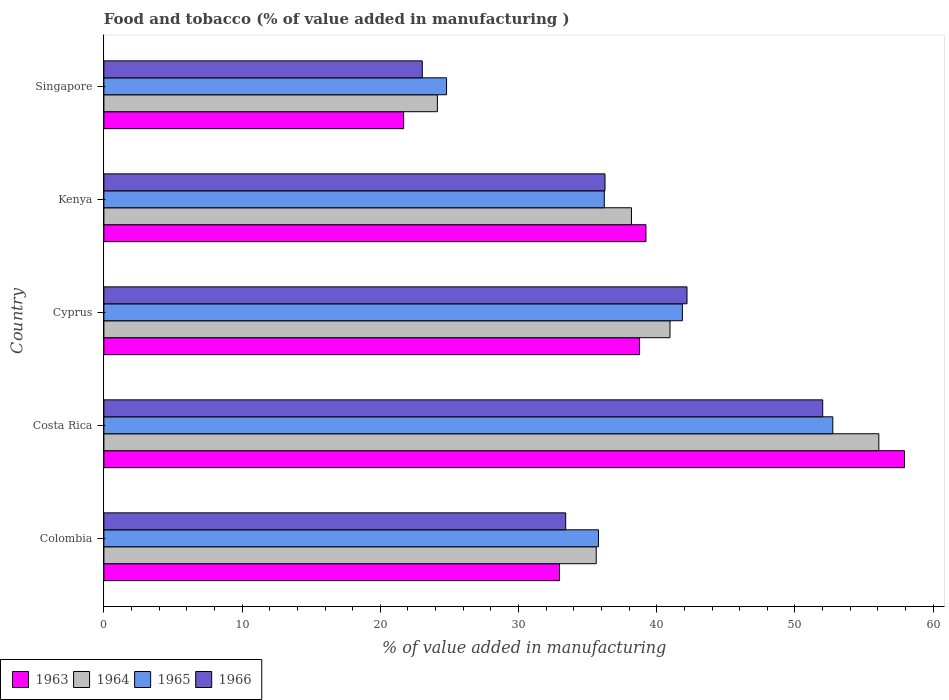How many groups of bars are there?
Provide a short and direct response. 5. How many bars are there on the 2nd tick from the bottom?
Your response must be concise. 4. What is the label of the 4th group of bars from the top?
Ensure brevity in your answer.  Costa Rica. What is the value added in manufacturing food and tobacco in 1965 in Colombia?
Provide a short and direct response. 35.78. Across all countries, what is the maximum value added in manufacturing food and tobacco in 1965?
Keep it short and to the point. 52.73. Across all countries, what is the minimum value added in manufacturing food and tobacco in 1965?
Your answer should be very brief. 24.79. In which country was the value added in manufacturing food and tobacco in 1964 minimum?
Make the answer very short. Singapore. What is the total value added in manufacturing food and tobacco in 1965 in the graph?
Offer a very short reply. 191.36. What is the difference between the value added in manufacturing food and tobacco in 1966 in Cyprus and that in Kenya?
Offer a terse response. 5.93. What is the difference between the value added in manufacturing food and tobacco in 1965 in Kenya and the value added in manufacturing food and tobacco in 1966 in Costa Rica?
Give a very brief answer. -15.8. What is the average value added in manufacturing food and tobacco in 1963 per country?
Offer a terse response. 38.11. What is the difference between the value added in manufacturing food and tobacco in 1963 and value added in manufacturing food and tobacco in 1966 in Colombia?
Your answer should be compact. -0.45. In how many countries, is the value added in manufacturing food and tobacco in 1965 greater than 6 %?
Provide a succinct answer. 5. What is the ratio of the value added in manufacturing food and tobacco in 1964 in Colombia to that in Cyprus?
Give a very brief answer. 0.87. Is the value added in manufacturing food and tobacco in 1964 in Cyprus less than that in Singapore?
Ensure brevity in your answer.  No. Is the difference between the value added in manufacturing food and tobacco in 1963 in Costa Rica and Kenya greater than the difference between the value added in manufacturing food and tobacco in 1966 in Costa Rica and Kenya?
Ensure brevity in your answer.  Yes. What is the difference between the highest and the second highest value added in manufacturing food and tobacco in 1964?
Ensure brevity in your answer.  15.11. What is the difference between the highest and the lowest value added in manufacturing food and tobacco in 1964?
Give a very brief answer. 31.94. In how many countries, is the value added in manufacturing food and tobacco in 1966 greater than the average value added in manufacturing food and tobacco in 1966 taken over all countries?
Ensure brevity in your answer.  2. What does the 3rd bar from the top in Kenya represents?
Your response must be concise. 1964. What does the 2nd bar from the bottom in Singapore represents?
Make the answer very short. 1964. Is it the case that in every country, the sum of the value added in manufacturing food and tobacco in 1965 and value added in manufacturing food and tobacco in 1964 is greater than the value added in manufacturing food and tobacco in 1966?
Your answer should be compact. Yes. What is the difference between two consecutive major ticks on the X-axis?
Offer a very short reply. 10. Where does the legend appear in the graph?
Offer a terse response. Bottom left. How many legend labels are there?
Make the answer very short. 4. How are the legend labels stacked?
Give a very brief answer. Horizontal. What is the title of the graph?
Offer a very short reply. Food and tobacco (% of value added in manufacturing ). Does "1997" appear as one of the legend labels in the graph?
Keep it short and to the point. No. What is the label or title of the X-axis?
Give a very brief answer. % of value added in manufacturing. What is the % of value added in manufacturing in 1963 in Colombia?
Give a very brief answer. 32.96. What is the % of value added in manufacturing of 1964 in Colombia?
Give a very brief answer. 35.62. What is the % of value added in manufacturing of 1965 in Colombia?
Your answer should be very brief. 35.78. What is the % of value added in manufacturing of 1966 in Colombia?
Make the answer very short. 33.41. What is the % of value added in manufacturing of 1963 in Costa Rica?
Make the answer very short. 57.92. What is the % of value added in manufacturing of 1964 in Costa Rica?
Keep it short and to the point. 56.07. What is the % of value added in manufacturing in 1965 in Costa Rica?
Offer a terse response. 52.73. What is the % of value added in manufacturing in 1966 in Costa Rica?
Offer a very short reply. 52. What is the % of value added in manufacturing in 1963 in Cyprus?
Provide a short and direct response. 38.75. What is the % of value added in manufacturing of 1964 in Cyprus?
Offer a terse response. 40.96. What is the % of value added in manufacturing in 1965 in Cyprus?
Your response must be concise. 41.85. What is the % of value added in manufacturing of 1966 in Cyprus?
Provide a succinct answer. 42.19. What is the % of value added in manufacturing of 1963 in Kenya?
Your answer should be very brief. 39.22. What is the % of value added in manufacturing in 1964 in Kenya?
Give a very brief answer. 38.17. What is the % of value added in manufacturing of 1965 in Kenya?
Your response must be concise. 36.2. What is the % of value added in manufacturing in 1966 in Kenya?
Ensure brevity in your answer.  36.25. What is the % of value added in manufacturing in 1963 in Singapore?
Ensure brevity in your answer.  21.69. What is the % of value added in manufacturing in 1964 in Singapore?
Keep it short and to the point. 24.13. What is the % of value added in manufacturing of 1965 in Singapore?
Keep it short and to the point. 24.79. What is the % of value added in manufacturing of 1966 in Singapore?
Your response must be concise. 23.04. Across all countries, what is the maximum % of value added in manufacturing of 1963?
Ensure brevity in your answer.  57.92. Across all countries, what is the maximum % of value added in manufacturing in 1964?
Give a very brief answer. 56.07. Across all countries, what is the maximum % of value added in manufacturing in 1965?
Offer a terse response. 52.73. Across all countries, what is the maximum % of value added in manufacturing of 1966?
Offer a terse response. 52. Across all countries, what is the minimum % of value added in manufacturing in 1963?
Provide a short and direct response. 21.69. Across all countries, what is the minimum % of value added in manufacturing in 1964?
Your response must be concise. 24.13. Across all countries, what is the minimum % of value added in manufacturing of 1965?
Provide a short and direct response. 24.79. Across all countries, what is the minimum % of value added in manufacturing in 1966?
Your answer should be compact. 23.04. What is the total % of value added in manufacturing of 1963 in the graph?
Give a very brief answer. 190.54. What is the total % of value added in manufacturing of 1964 in the graph?
Your answer should be very brief. 194.94. What is the total % of value added in manufacturing of 1965 in the graph?
Your answer should be very brief. 191.36. What is the total % of value added in manufacturing of 1966 in the graph?
Your answer should be compact. 186.89. What is the difference between the % of value added in manufacturing of 1963 in Colombia and that in Costa Rica?
Your answer should be very brief. -24.96. What is the difference between the % of value added in manufacturing of 1964 in Colombia and that in Costa Rica?
Your answer should be compact. -20.45. What is the difference between the % of value added in manufacturing of 1965 in Colombia and that in Costa Rica?
Give a very brief answer. -16.95. What is the difference between the % of value added in manufacturing of 1966 in Colombia and that in Costa Rica?
Your answer should be compact. -18.59. What is the difference between the % of value added in manufacturing of 1963 in Colombia and that in Cyprus?
Give a very brief answer. -5.79. What is the difference between the % of value added in manufacturing in 1964 in Colombia and that in Cyprus?
Your answer should be very brief. -5.34. What is the difference between the % of value added in manufacturing in 1965 in Colombia and that in Cyprus?
Your answer should be compact. -6.07. What is the difference between the % of value added in manufacturing in 1966 in Colombia and that in Cyprus?
Provide a short and direct response. -8.78. What is the difference between the % of value added in manufacturing of 1963 in Colombia and that in Kenya?
Give a very brief answer. -6.26. What is the difference between the % of value added in manufacturing in 1964 in Colombia and that in Kenya?
Keep it short and to the point. -2.55. What is the difference between the % of value added in manufacturing of 1965 in Colombia and that in Kenya?
Your answer should be compact. -0.42. What is the difference between the % of value added in manufacturing in 1966 in Colombia and that in Kenya?
Provide a short and direct response. -2.84. What is the difference between the % of value added in manufacturing in 1963 in Colombia and that in Singapore?
Give a very brief answer. 11.27. What is the difference between the % of value added in manufacturing of 1964 in Colombia and that in Singapore?
Your response must be concise. 11.49. What is the difference between the % of value added in manufacturing in 1965 in Colombia and that in Singapore?
Your answer should be very brief. 10.99. What is the difference between the % of value added in manufacturing in 1966 in Colombia and that in Singapore?
Keep it short and to the point. 10.37. What is the difference between the % of value added in manufacturing of 1963 in Costa Rica and that in Cyprus?
Offer a terse response. 19.17. What is the difference between the % of value added in manufacturing of 1964 in Costa Rica and that in Cyprus?
Your response must be concise. 15.11. What is the difference between the % of value added in manufacturing of 1965 in Costa Rica and that in Cyprus?
Your answer should be very brief. 10.88. What is the difference between the % of value added in manufacturing in 1966 in Costa Rica and that in Cyprus?
Ensure brevity in your answer.  9.82. What is the difference between the % of value added in manufacturing in 1963 in Costa Rica and that in Kenya?
Keep it short and to the point. 18.7. What is the difference between the % of value added in manufacturing in 1964 in Costa Rica and that in Kenya?
Provide a succinct answer. 17.9. What is the difference between the % of value added in manufacturing in 1965 in Costa Rica and that in Kenya?
Provide a short and direct response. 16.53. What is the difference between the % of value added in manufacturing in 1966 in Costa Rica and that in Kenya?
Offer a terse response. 15.75. What is the difference between the % of value added in manufacturing in 1963 in Costa Rica and that in Singapore?
Your response must be concise. 36.23. What is the difference between the % of value added in manufacturing in 1964 in Costa Rica and that in Singapore?
Your response must be concise. 31.94. What is the difference between the % of value added in manufacturing in 1965 in Costa Rica and that in Singapore?
Provide a succinct answer. 27.94. What is the difference between the % of value added in manufacturing in 1966 in Costa Rica and that in Singapore?
Offer a terse response. 28.97. What is the difference between the % of value added in manufacturing of 1963 in Cyprus and that in Kenya?
Ensure brevity in your answer.  -0.46. What is the difference between the % of value added in manufacturing of 1964 in Cyprus and that in Kenya?
Your response must be concise. 2.79. What is the difference between the % of value added in manufacturing in 1965 in Cyprus and that in Kenya?
Your response must be concise. 5.65. What is the difference between the % of value added in manufacturing of 1966 in Cyprus and that in Kenya?
Give a very brief answer. 5.93. What is the difference between the % of value added in manufacturing of 1963 in Cyprus and that in Singapore?
Give a very brief answer. 17.07. What is the difference between the % of value added in manufacturing in 1964 in Cyprus and that in Singapore?
Provide a short and direct response. 16.83. What is the difference between the % of value added in manufacturing in 1965 in Cyprus and that in Singapore?
Give a very brief answer. 17.06. What is the difference between the % of value added in manufacturing of 1966 in Cyprus and that in Singapore?
Give a very brief answer. 19.15. What is the difference between the % of value added in manufacturing of 1963 in Kenya and that in Singapore?
Offer a very short reply. 17.53. What is the difference between the % of value added in manufacturing of 1964 in Kenya and that in Singapore?
Your response must be concise. 14.04. What is the difference between the % of value added in manufacturing in 1965 in Kenya and that in Singapore?
Provide a short and direct response. 11.41. What is the difference between the % of value added in manufacturing of 1966 in Kenya and that in Singapore?
Your answer should be very brief. 13.22. What is the difference between the % of value added in manufacturing of 1963 in Colombia and the % of value added in manufacturing of 1964 in Costa Rica?
Offer a terse response. -23.11. What is the difference between the % of value added in manufacturing in 1963 in Colombia and the % of value added in manufacturing in 1965 in Costa Rica?
Keep it short and to the point. -19.77. What is the difference between the % of value added in manufacturing of 1963 in Colombia and the % of value added in manufacturing of 1966 in Costa Rica?
Give a very brief answer. -19.04. What is the difference between the % of value added in manufacturing of 1964 in Colombia and the % of value added in manufacturing of 1965 in Costa Rica?
Provide a short and direct response. -17.11. What is the difference between the % of value added in manufacturing in 1964 in Colombia and the % of value added in manufacturing in 1966 in Costa Rica?
Give a very brief answer. -16.38. What is the difference between the % of value added in manufacturing in 1965 in Colombia and the % of value added in manufacturing in 1966 in Costa Rica?
Your answer should be very brief. -16.22. What is the difference between the % of value added in manufacturing of 1963 in Colombia and the % of value added in manufacturing of 1964 in Cyprus?
Your response must be concise. -8. What is the difference between the % of value added in manufacturing of 1963 in Colombia and the % of value added in manufacturing of 1965 in Cyprus?
Provide a succinct answer. -8.89. What is the difference between the % of value added in manufacturing of 1963 in Colombia and the % of value added in manufacturing of 1966 in Cyprus?
Provide a short and direct response. -9.23. What is the difference between the % of value added in manufacturing of 1964 in Colombia and the % of value added in manufacturing of 1965 in Cyprus?
Make the answer very short. -6.23. What is the difference between the % of value added in manufacturing in 1964 in Colombia and the % of value added in manufacturing in 1966 in Cyprus?
Offer a very short reply. -6.57. What is the difference between the % of value added in manufacturing in 1965 in Colombia and the % of value added in manufacturing in 1966 in Cyprus?
Your response must be concise. -6.41. What is the difference between the % of value added in manufacturing in 1963 in Colombia and the % of value added in manufacturing in 1964 in Kenya?
Offer a very short reply. -5.21. What is the difference between the % of value added in manufacturing of 1963 in Colombia and the % of value added in manufacturing of 1965 in Kenya?
Give a very brief answer. -3.24. What is the difference between the % of value added in manufacturing in 1963 in Colombia and the % of value added in manufacturing in 1966 in Kenya?
Make the answer very short. -3.29. What is the difference between the % of value added in manufacturing in 1964 in Colombia and the % of value added in manufacturing in 1965 in Kenya?
Keep it short and to the point. -0.58. What is the difference between the % of value added in manufacturing of 1964 in Colombia and the % of value added in manufacturing of 1966 in Kenya?
Your answer should be very brief. -0.63. What is the difference between the % of value added in manufacturing of 1965 in Colombia and the % of value added in manufacturing of 1966 in Kenya?
Offer a terse response. -0.47. What is the difference between the % of value added in manufacturing in 1963 in Colombia and the % of value added in manufacturing in 1964 in Singapore?
Ensure brevity in your answer.  8.83. What is the difference between the % of value added in manufacturing in 1963 in Colombia and the % of value added in manufacturing in 1965 in Singapore?
Provide a succinct answer. 8.17. What is the difference between the % of value added in manufacturing in 1963 in Colombia and the % of value added in manufacturing in 1966 in Singapore?
Offer a terse response. 9.92. What is the difference between the % of value added in manufacturing of 1964 in Colombia and the % of value added in manufacturing of 1965 in Singapore?
Ensure brevity in your answer.  10.83. What is the difference between the % of value added in manufacturing in 1964 in Colombia and the % of value added in manufacturing in 1966 in Singapore?
Provide a succinct answer. 12.58. What is the difference between the % of value added in manufacturing in 1965 in Colombia and the % of value added in manufacturing in 1966 in Singapore?
Your answer should be compact. 12.74. What is the difference between the % of value added in manufacturing in 1963 in Costa Rica and the % of value added in manufacturing in 1964 in Cyprus?
Your answer should be compact. 16.96. What is the difference between the % of value added in manufacturing of 1963 in Costa Rica and the % of value added in manufacturing of 1965 in Cyprus?
Your answer should be compact. 16.07. What is the difference between the % of value added in manufacturing of 1963 in Costa Rica and the % of value added in manufacturing of 1966 in Cyprus?
Ensure brevity in your answer.  15.73. What is the difference between the % of value added in manufacturing of 1964 in Costa Rica and the % of value added in manufacturing of 1965 in Cyprus?
Your response must be concise. 14.21. What is the difference between the % of value added in manufacturing of 1964 in Costa Rica and the % of value added in manufacturing of 1966 in Cyprus?
Your answer should be very brief. 13.88. What is the difference between the % of value added in manufacturing in 1965 in Costa Rica and the % of value added in manufacturing in 1966 in Cyprus?
Provide a short and direct response. 10.55. What is the difference between the % of value added in manufacturing in 1963 in Costa Rica and the % of value added in manufacturing in 1964 in Kenya?
Make the answer very short. 19.75. What is the difference between the % of value added in manufacturing of 1963 in Costa Rica and the % of value added in manufacturing of 1965 in Kenya?
Provide a short and direct response. 21.72. What is the difference between the % of value added in manufacturing of 1963 in Costa Rica and the % of value added in manufacturing of 1966 in Kenya?
Offer a terse response. 21.67. What is the difference between the % of value added in manufacturing of 1964 in Costa Rica and the % of value added in manufacturing of 1965 in Kenya?
Make the answer very short. 19.86. What is the difference between the % of value added in manufacturing in 1964 in Costa Rica and the % of value added in manufacturing in 1966 in Kenya?
Give a very brief answer. 19.81. What is the difference between the % of value added in manufacturing of 1965 in Costa Rica and the % of value added in manufacturing of 1966 in Kenya?
Provide a short and direct response. 16.48. What is the difference between the % of value added in manufacturing of 1963 in Costa Rica and the % of value added in manufacturing of 1964 in Singapore?
Offer a very short reply. 33.79. What is the difference between the % of value added in manufacturing in 1963 in Costa Rica and the % of value added in manufacturing in 1965 in Singapore?
Ensure brevity in your answer.  33.13. What is the difference between the % of value added in manufacturing in 1963 in Costa Rica and the % of value added in manufacturing in 1966 in Singapore?
Provide a succinct answer. 34.88. What is the difference between the % of value added in manufacturing of 1964 in Costa Rica and the % of value added in manufacturing of 1965 in Singapore?
Your answer should be compact. 31.28. What is the difference between the % of value added in manufacturing in 1964 in Costa Rica and the % of value added in manufacturing in 1966 in Singapore?
Keep it short and to the point. 33.03. What is the difference between the % of value added in manufacturing of 1965 in Costa Rica and the % of value added in manufacturing of 1966 in Singapore?
Keep it short and to the point. 29.7. What is the difference between the % of value added in manufacturing in 1963 in Cyprus and the % of value added in manufacturing in 1964 in Kenya?
Keep it short and to the point. 0.59. What is the difference between the % of value added in manufacturing in 1963 in Cyprus and the % of value added in manufacturing in 1965 in Kenya?
Provide a short and direct response. 2.55. What is the difference between the % of value added in manufacturing of 1963 in Cyprus and the % of value added in manufacturing of 1966 in Kenya?
Your response must be concise. 2.5. What is the difference between the % of value added in manufacturing in 1964 in Cyprus and the % of value added in manufacturing in 1965 in Kenya?
Offer a terse response. 4.75. What is the difference between the % of value added in manufacturing of 1964 in Cyprus and the % of value added in manufacturing of 1966 in Kenya?
Your answer should be very brief. 4.7. What is the difference between the % of value added in manufacturing of 1965 in Cyprus and the % of value added in manufacturing of 1966 in Kenya?
Offer a terse response. 5.6. What is the difference between the % of value added in manufacturing of 1963 in Cyprus and the % of value added in manufacturing of 1964 in Singapore?
Offer a very short reply. 14.63. What is the difference between the % of value added in manufacturing in 1963 in Cyprus and the % of value added in manufacturing in 1965 in Singapore?
Provide a succinct answer. 13.96. What is the difference between the % of value added in manufacturing in 1963 in Cyprus and the % of value added in manufacturing in 1966 in Singapore?
Offer a very short reply. 15.72. What is the difference between the % of value added in manufacturing in 1964 in Cyprus and the % of value added in manufacturing in 1965 in Singapore?
Your response must be concise. 16.17. What is the difference between the % of value added in manufacturing in 1964 in Cyprus and the % of value added in manufacturing in 1966 in Singapore?
Keep it short and to the point. 17.92. What is the difference between the % of value added in manufacturing in 1965 in Cyprus and the % of value added in manufacturing in 1966 in Singapore?
Provide a short and direct response. 18.82. What is the difference between the % of value added in manufacturing of 1963 in Kenya and the % of value added in manufacturing of 1964 in Singapore?
Keep it short and to the point. 15.09. What is the difference between the % of value added in manufacturing of 1963 in Kenya and the % of value added in manufacturing of 1965 in Singapore?
Make the answer very short. 14.43. What is the difference between the % of value added in manufacturing of 1963 in Kenya and the % of value added in manufacturing of 1966 in Singapore?
Your answer should be very brief. 16.18. What is the difference between the % of value added in manufacturing in 1964 in Kenya and the % of value added in manufacturing in 1965 in Singapore?
Your response must be concise. 13.38. What is the difference between the % of value added in manufacturing of 1964 in Kenya and the % of value added in manufacturing of 1966 in Singapore?
Provide a short and direct response. 15.13. What is the difference between the % of value added in manufacturing in 1965 in Kenya and the % of value added in manufacturing in 1966 in Singapore?
Your answer should be very brief. 13.17. What is the average % of value added in manufacturing in 1963 per country?
Your response must be concise. 38.11. What is the average % of value added in manufacturing in 1964 per country?
Provide a short and direct response. 38.99. What is the average % of value added in manufacturing in 1965 per country?
Keep it short and to the point. 38.27. What is the average % of value added in manufacturing in 1966 per country?
Offer a terse response. 37.38. What is the difference between the % of value added in manufacturing of 1963 and % of value added in manufacturing of 1964 in Colombia?
Provide a short and direct response. -2.66. What is the difference between the % of value added in manufacturing of 1963 and % of value added in manufacturing of 1965 in Colombia?
Make the answer very short. -2.82. What is the difference between the % of value added in manufacturing of 1963 and % of value added in manufacturing of 1966 in Colombia?
Provide a succinct answer. -0.45. What is the difference between the % of value added in manufacturing of 1964 and % of value added in manufacturing of 1965 in Colombia?
Your response must be concise. -0.16. What is the difference between the % of value added in manufacturing of 1964 and % of value added in manufacturing of 1966 in Colombia?
Offer a terse response. 2.21. What is the difference between the % of value added in manufacturing of 1965 and % of value added in manufacturing of 1966 in Colombia?
Your answer should be compact. 2.37. What is the difference between the % of value added in manufacturing in 1963 and % of value added in manufacturing in 1964 in Costa Rica?
Offer a terse response. 1.85. What is the difference between the % of value added in manufacturing in 1963 and % of value added in manufacturing in 1965 in Costa Rica?
Give a very brief answer. 5.19. What is the difference between the % of value added in manufacturing of 1963 and % of value added in manufacturing of 1966 in Costa Rica?
Your response must be concise. 5.92. What is the difference between the % of value added in manufacturing in 1964 and % of value added in manufacturing in 1965 in Costa Rica?
Provide a short and direct response. 3.33. What is the difference between the % of value added in manufacturing in 1964 and % of value added in manufacturing in 1966 in Costa Rica?
Keep it short and to the point. 4.06. What is the difference between the % of value added in manufacturing of 1965 and % of value added in manufacturing of 1966 in Costa Rica?
Offer a terse response. 0.73. What is the difference between the % of value added in manufacturing in 1963 and % of value added in manufacturing in 1964 in Cyprus?
Offer a very short reply. -2.2. What is the difference between the % of value added in manufacturing in 1963 and % of value added in manufacturing in 1965 in Cyprus?
Keep it short and to the point. -3.1. What is the difference between the % of value added in manufacturing in 1963 and % of value added in manufacturing in 1966 in Cyprus?
Your answer should be compact. -3.43. What is the difference between the % of value added in manufacturing of 1964 and % of value added in manufacturing of 1965 in Cyprus?
Your answer should be compact. -0.9. What is the difference between the % of value added in manufacturing of 1964 and % of value added in manufacturing of 1966 in Cyprus?
Provide a succinct answer. -1.23. What is the difference between the % of value added in manufacturing in 1965 and % of value added in manufacturing in 1966 in Cyprus?
Your response must be concise. -0.33. What is the difference between the % of value added in manufacturing in 1963 and % of value added in manufacturing in 1964 in Kenya?
Your answer should be very brief. 1.05. What is the difference between the % of value added in manufacturing in 1963 and % of value added in manufacturing in 1965 in Kenya?
Offer a very short reply. 3.01. What is the difference between the % of value added in manufacturing in 1963 and % of value added in manufacturing in 1966 in Kenya?
Your answer should be compact. 2.96. What is the difference between the % of value added in manufacturing of 1964 and % of value added in manufacturing of 1965 in Kenya?
Offer a terse response. 1.96. What is the difference between the % of value added in manufacturing of 1964 and % of value added in manufacturing of 1966 in Kenya?
Offer a terse response. 1.91. What is the difference between the % of value added in manufacturing in 1963 and % of value added in manufacturing in 1964 in Singapore?
Your response must be concise. -2.44. What is the difference between the % of value added in manufacturing in 1963 and % of value added in manufacturing in 1965 in Singapore?
Make the answer very short. -3.1. What is the difference between the % of value added in manufacturing in 1963 and % of value added in manufacturing in 1966 in Singapore?
Offer a terse response. -1.35. What is the difference between the % of value added in manufacturing in 1964 and % of value added in manufacturing in 1965 in Singapore?
Make the answer very short. -0.66. What is the difference between the % of value added in manufacturing in 1964 and % of value added in manufacturing in 1966 in Singapore?
Your response must be concise. 1.09. What is the difference between the % of value added in manufacturing in 1965 and % of value added in manufacturing in 1966 in Singapore?
Keep it short and to the point. 1.75. What is the ratio of the % of value added in manufacturing in 1963 in Colombia to that in Costa Rica?
Your response must be concise. 0.57. What is the ratio of the % of value added in manufacturing in 1964 in Colombia to that in Costa Rica?
Your answer should be very brief. 0.64. What is the ratio of the % of value added in manufacturing in 1965 in Colombia to that in Costa Rica?
Provide a short and direct response. 0.68. What is the ratio of the % of value added in manufacturing in 1966 in Colombia to that in Costa Rica?
Offer a terse response. 0.64. What is the ratio of the % of value added in manufacturing in 1963 in Colombia to that in Cyprus?
Your answer should be very brief. 0.85. What is the ratio of the % of value added in manufacturing in 1964 in Colombia to that in Cyprus?
Ensure brevity in your answer.  0.87. What is the ratio of the % of value added in manufacturing of 1965 in Colombia to that in Cyprus?
Your answer should be compact. 0.85. What is the ratio of the % of value added in manufacturing in 1966 in Colombia to that in Cyprus?
Your answer should be very brief. 0.79. What is the ratio of the % of value added in manufacturing of 1963 in Colombia to that in Kenya?
Keep it short and to the point. 0.84. What is the ratio of the % of value added in manufacturing of 1964 in Colombia to that in Kenya?
Provide a short and direct response. 0.93. What is the ratio of the % of value added in manufacturing of 1965 in Colombia to that in Kenya?
Make the answer very short. 0.99. What is the ratio of the % of value added in manufacturing in 1966 in Colombia to that in Kenya?
Provide a short and direct response. 0.92. What is the ratio of the % of value added in manufacturing in 1963 in Colombia to that in Singapore?
Make the answer very short. 1.52. What is the ratio of the % of value added in manufacturing of 1964 in Colombia to that in Singapore?
Provide a succinct answer. 1.48. What is the ratio of the % of value added in manufacturing in 1965 in Colombia to that in Singapore?
Provide a short and direct response. 1.44. What is the ratio of the % of value added in manufacturing in 1966 in Colombia to that in Singapore?
Your answer should be compact. 1.45. What is the ratio of the % of value added in manufacturing of 1963 in Costa Rica to that in Cyprus?
Give a very brief answer. 1.49. What is the ratio of the % of value added in manufacturing of 1964 in Costa Rica to that in Cyprus?
Your response must be concise. 1.37. What is the ratio of the % of value added in manufacturing in 1965 in Costa Rica to that in Cyprus?
Ensure brevity in your answer.  1.26. What is the ratio of the % of value added in manufacturing of 1966 in Costa Rica to that in Cyprus?
Keep it short and to the point. 1.23. What is the ratio of the % of value added in manufacturing of 1963 in Costa Rica to that in Kenya?
Your response must be concise. 1.48. What is the ratio of the % of value added in manufacturing in 1964 in Costa Rica to that in Kenya?
Keep it short and to the point. 1.47. What is the ratio of the % of value added in manufacturing in 1965 in Costa Rica to that in Kenya?
Offer a very short reply. 1.46. What is the ratio of the % of value added in manufacturing of 1966 in Costa Rica to that in Kenya?
Your answer should be compact. 1.43. What is the ratio of the % of value added in manufacturing of 1963 in Costa Rica to that in Singapore?
Make the answer very short. 2.67. What is the ratio of the % of value added in manufacturing of 1964 in Costa Rica to that in Singapore?
Your response must be concise. 2.32. What is the ratio of the % of value added in manufacturing of 1965 in Costa Rica to that in Singapore?
Keep it short and to the point. 2.13. What is the ratio of the % of value added in manufacturing of 1966 in Costa Rica to that in Singapore?
Give a very brief answer. 2.26. What is the ratio of the % of value added in manufacturing in 1963 in Cyprus to that in Kenya?
Your response must be concise. 0.99. What is the ratio of the % of value added in manufacturing in 1964 in Cyprus to that in Kenya?
Offer a very short reply. 1.07. What is the ratio of the % of value added in manufacturing of 1965 in Cyprus to that in Kenya?
Your response must be concise. 1.16. What is the ratio of the % of value added in manufacturing of 1966 in Cyprus to that in Kenya?
Your answer should be very brief. 1.16. What is the ratio of the % of value added in manufacturing of 1963 in Cyprus to that in Singapore?
Provide a short and direct response. 1.79. What is the ratio of the % of value added in manufacturing of 1964 in Cyprus to that in Singapore?
Make the answer very short. 1.7. What is the ratio of the % of value added in manufacturing in 1965 in Cyprus to that in Singapore?
Offer a terse response. 1.69. What is the ratio of the % of value added in manufacturing of 1966 in Cyprus to that in Singapore?
Your answer should be compact. 1.83. What is the ratio of the % of value added in manufacturing in 1963 in Kenya to that in Singapore?
Offer a very short reply. 1.81. What is the ratio of the % of value added in manufacturing in 1964 in Kenya to that in Singapore?
Give a very brief answer. 1.58. What is the ratio of the % of value added in manufacturing in 1965 in Kenya to that in Singapore?
Your response must be concise. 1.46. What is the ratio of the % of value added in manufacturing of 1966 in Kenya to that in Singapore?
Provide a short and direct response. 1.57. What is the difference between the highest and the second highest % of value added in manufacturing in 1963?
Your response must be concise. 18.7. What is the difference between the highest and the second highest % of value added in manufacturing of 1964?
Provide a short and direct response. 15.11. What is the difference between the highest and the second highest % of value added in manufacturing in 1965?
Offer a very short reply. 10.88. What is the difference between the highest and the second highest % of value added in manufacturing of 1966?
Your answer should be compact. 9.82. What is the difference between the highest and the lowest % of value added in manufacturing in 1963?
Your answer should be compact. 36.23. What is the difference between the highest and the lowest % of value added in manufacturing in 1964?
Your response must be concise. 31.94. What is the difference between the highest and the lowest % of value added in manufacturing in 1965?
Provide a short and direct response. 27.94. What is the difference between the highest and the lowest % of value added in manufacturing of 1966?
Ensure brevity in your answer.  28.97. 